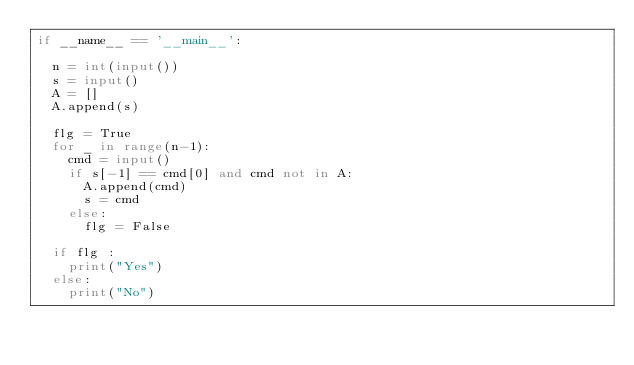<code> <loc_0><loc_0><loc_500><loc_500><_Python_>if __name__ == '__main__':

	n = int(input())
	s = input()
	A = []
	A.append(s)

	flg = True
	for _ in range(n-1):
		cmd = input()
		if s[-1] == cmd[0] and cmd not in A:
			A.append(cmd)
			s = cmd
		else:
			flg = False

	if flg :
		print("Yes")
	else:
		print("No")
</code> 